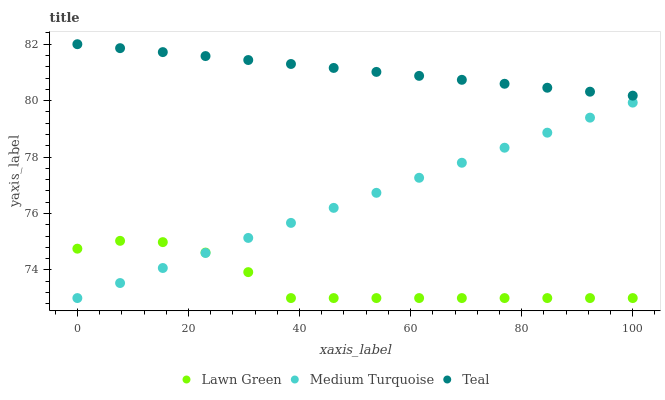Does Lawn Green have the minimum area under the curve?
Answer yes or no. Yes. Does Teal have the maximum area under the curve?
Answer yes or no. Yes. Does Medium Turquoise have the minimum area under the curve?
Answer yes or no. No. Does Medium Turquoise have the maximum area under the curve?
Answer yes or no. No. Is Teal the smoothest?
Answer yes or no. Yes. Is Lawn Green the roughest?
Answer yes or no. Yes. Is Medium Turquoise the smoothest?
Answer yes or no. No. Is Medium Turquoise the roughest?
Answer yes or no. No. Does Lawn Green have the lowest value?
Answer yes or no. Yes. Does Teal have the lowest value?
Answer yes or no. No. Does Teal have the highest value?
Answer yes or no. Yes. Does Medium Turquoise have the highest value?
Answer yes or no. No. Is Lawn Green less than Teal?
Answer yes or no. Yes. Is Teal greater than Medium Turquoise?
Answer yes or no. Yes. Does Lawn Green intersect Medium Turquoise?
Answer yes or no. Yes. Is Lawn Green less than Medium Turquoise?
Answer yes or no. No. Is Lawn Green greater than Medium Turquoise?
Answer yes or no. No. Does Lawn Green intersect Teal?
Answer yes or no. No. 